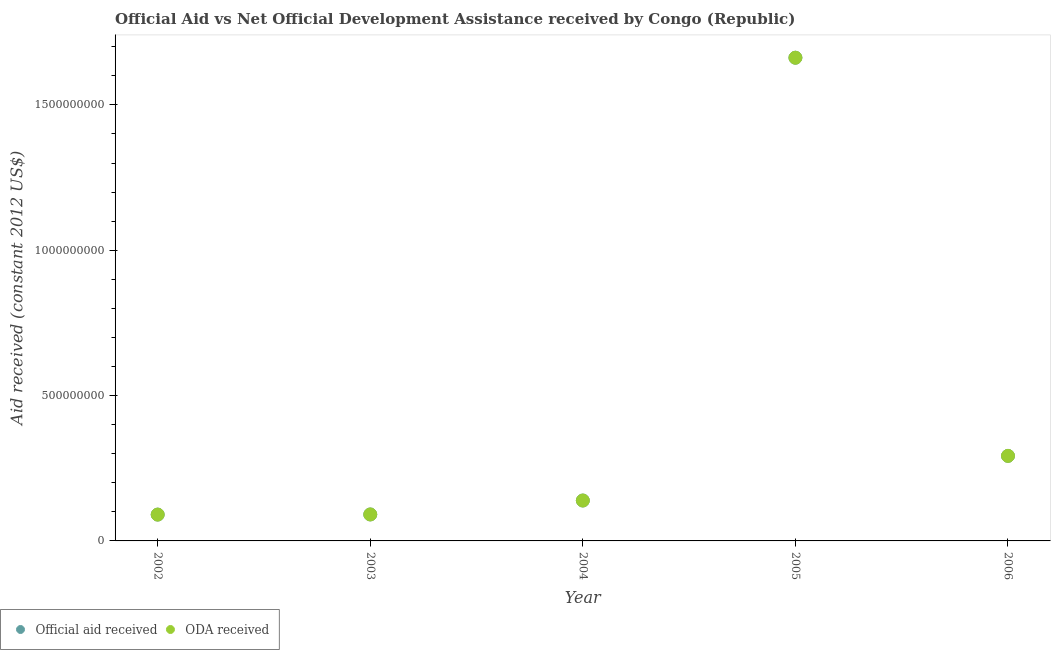How many different coloured dotlines are there?
Offer a very short reply. 2. What is the oda received in 2002?
Your answer should be compact. 9.06e+07. Across all years, what is the maximum official aid received?
Your response must be concise. 1.66e+09. Across all years, what is the minimum oda received?
Your answer should be compact. 9.06e+07. In which year was the oda received maximum?
Provide a short and direct response. 2005. In which year was the official aid received minimum?
Offer a terse response. 2002. What is the total official aid received in the graph?
Your response must be concise. 2.28e+09. What is the difference between the official aid received in 2005 and that in 2006?
Your answer should be compact. 1.37e+09. What is the difference between the official aid received in 2002 and the oda received in 2005?
Offer a very short reply. -1.57e+09. What is the average official aid received per year?
Provide a succinct answer. 4.55e+08. In the year 2005, what is the difference between the oda received and official aid received?
Your answer should be compact. 0. What is the ratio of the official aid received in 2004 to that in 2005?
Your response must be concise. 0.08. Is the difference between the official aid received in 2002 and 2006 greater than the difference between the oda received in 2002 and 2006?
Provide a short and direct response. No. What is the difference between the highest and the second highest oda received?
Offer a terse response. 1.37e+09. What is the difference between the highest and the lowest official aid received?
Keep it short and to the point. 1.57e+09. Is the sum of the official aid received in 2003 and 2004 greater than the maximum oda received across all years?
Ensure brevity in your answer.  No. Is the oda received strictly greater than the official aid received over the years?
Your answer should be very brief. No. Is the oda received strictly less than the official aid received over the years?
Your answer should be very brief. No. What is the difference between two consecutive major ticks on the Y-axis?
Offer a very short reply. 5.00e+08. How are the legend labels stacked?
Provide a succinct answer. Horizontal. What is the title of the graph?
Offer a terse response. Official Aid vs Net Official Development Assistance received by Congo (Republic) . What is the label or title of the X-axis?
Offer a terse response. Year. What is the label or title of the Y-axis?
Your answer should be compact. Aid received (constant 2012 US$). What is the Aid received (constant 2012 US$) in Official aid received in 2002?
Give a very brief answer. 9.06e+07. What is the Aid received (constant 2012 US$) in ODA received in 2002?
Ensure brevity in your answer.  9.06e+07. What is the Aid received (constant 2012 US$) of Official aid received in 2003?
Provide a short and direct response. 9.11e+07. What is the Aid received (constant 2012 US$) in ODA received in 2003?
Offer a terse response. 9.11e+07. What is the Aid received (constant 2012 US$) of Official aid received in 2004?
Give a very brief answer. 1.39e+08. What is the Aid received (constant 2012 US$) of ODA received in 2004?
Offer a very short reply. 1.39e+08. What is the Aid received (constant 2012 US$) of Official aid received in 2005?
Provide a succinct answer. 1.66e+09. What is the Aid received (constant 2012 US$) in ODA received in 2005?
Your answer should be very brief. 1.66e+09. What is the Aid received (constant 2012 US$) of Official aid received in 2006?
Provide a succinct answer. 2.93e+08. What is the Aid received (constant 2012 US$) in ODA received in 2006?
Make the answer very short. 2.93e+08. Across all years, what is the maximum Aid received (constant 2012 US$) of Official aid received?
Provide a short and direct response. 1.66e+09. Across all years, what is the maximum Aid received (constant 2012 US$) in ODA received?
Ensure brevity in your answer.  1.66e+09. Across all years, what is the minimum Aid received (constant 2012 US$) of Official aid received?
Make the answer very short. 9.06e+07. Across all years, what is the minimum Aid received (constant 2012 US$) of ODA received?
Provide a short and direct response. 9.06e+07. What is the total Aid received (constant 2012 US$) in Official aid received in the graph?
Offer a terse response. 2.28e+09. What is the total Aid received (constant 2012 US$) of ODA received in the graph?
Offer a very short reply. 2.28e+09. What is the difference between the Aid received (constant 2012 US$) in Official aid received in 2002 and that in 2003?
Your response must be concise. -5.00e+05. What is the difference between the Aid received (constant 2012 US$) in ODA received in 2002 and that in 2003?
Your answer should be very brief. -5.00e+05. What is the difference between the Aid received (constant 2012 US$) in Official aid received in 2002 and that in 2004?
Keep it short and to the point. -4.84e+07. What is the difference between the Aid received (constant 2012 US$) of ODA received in 2002 and that in 2004?
Provide a succinct answer. -4.84e+07. What is the difference between the Aid received (constant 2012 US$) of Official aid received in 2002 and that in 2005?
Give a very brief answer. -1.57e+09. What is the difference between the Aid received (constant 2012 US$) of ODA received in 2002 and that in 2005?
Keep it short and to the point. -1.57e+09. What is the difference between the Aid received (constant 2012 US$) in Official aid received in 2002 and that in 2006?
Provide a succinct answer. -2.02e+08. What is the difference between the Aid received (constant 2012 US$) in ODA received in 2002 and that in 2006?
Give a very brief answer. -2.02e+08. What is the difference between the Aid received (constant 2012 US$) of Official aid received in 2003 and that in 2004?
Give a very brief answer. -4.79e+07. What is the difference between the Aid received (constant 2012 US$) of ODA received in 2003 and that in 2004?
Offer a terse response. -4.79e+07. What is the difference between the Aid received (constant 2012 US$) in Official aid received in 2003 and that in 2005?
Your answer should be very brief. -1.57e+09. What is the difference between the Aid received (constant 2012 US$) of ODA received in 2003 and that in 2005?
Provide a short and direct response. -1.57e+09. What is the difference between the Aid received (constant 2012 US$) of Official aid received in 2003 and that in 2006?
Keep it short and to the point. -2.02e+08. What is the difference between the Aid received (constant 2012 US$) in ODA received in 2003 and that in 2006?
Offer a terse response. -2.02e+08. What is the difference between the Aid received (constant 2012 US$) of Official aid received in 2004 and that in 2005?
Ensure brevity in your answer.  -1.52e+09. What is the difference between the Aid received (constant 2012 US$) in ODA received in 2004 and that in 2005?
Ensure brevity in your answer.  -1.52e+09. What is the difference between the Aid received (constant 2012 US$) in Official aid received in 2004 and that in 2006?
Your answer should be compact. -1.54e+08. What is the difference between the Aid received (constant 2012 US$) of ODA received in 2004 and that in 2006?
Make the answer very short. -1.54e+08. What is the difference between the Aid received (constant 2012 US$) in Official aid received in 2005 and that in 2006?
Your response must be concise. 1.37e+09. What is the difference between the Aid received (constant 2012 US$) of ODA received in 2005 and that in 2006?
Keep it short and to the point. 1.37e+09. What is the difference between the Aid received (constant 2012 US$) in Official aid received in 2002 and the Aid received (constant 2012 US$) in ODA received in 2003?
Offer a very short reply. -5.00e+05. What is the difference between the Aid received (constant 2012 US$) of Official aid received in 2002 and the Aid received (constant 2012 US$) of ODA received in 2004?
Provide a succinct answer. -4.84e+07. What is the difference between the Aid received (constant 2012 US$) in Official aid received in 2002 and the Aid received (constant 2012 US$) in ODA received in 2005?
Keep it short and to the point. -1.57e+09. What is the difference between the Aid received (constant 2012 US$) in Official aid received in 2002 and the Aid received (constant 2012 US$) in ODA received in 2006?
Your answer should be compact. -2.02e+08. What is the difference between the Aid received (constant 2012 US$) in Official aid received in 2003 and the Aid received (constant 2012 US$) in ODA received in 2004?
Provide a succinct answer. -4.79e+07. What is the difference between the Aid received (constant 2012 US$) of Official aid received in 2003 and the Aid received (constant 2012 US$) of ODA received in 2005?
Your response must be concise. -1.57e+09. What is the difference between the Aid received (constant 2012 US$) of Official aid received in 2003 and the Aid received (constant 2012 US$) of ODA received in 2006?
Your answer should be very brief. -2.02e+08. What is the difference between the Aid received (constant 2012 US$) in Official aid received in 2004 and the Aid received (constant 2012 US$) in ODA received in 2005?
Offer a very short reply. -1.52e+09. What is the difference between the Aid received (constant 2012 US$) in Official aid received in 2004 and the Aid received (constant 2012 US$) in ODA received in 2006?
Your answer should be very brief. -1.54e+08. What is the difference between the Aid received (constant 2012 US$) of Official aid received in 2005 and the Aid received (constant 2012 US$) of ODA received in 2006?
Provide a succinct answer. 1.37e+09. What is the average Aid received (constant 2012 US$) in Official aid received per year?
Your answer should be compact. 4.55e+08. What is the average Aid received (constant 2012 US$) in ODA received per year?
Ensure brevity in your answer.  4.55e+08. In the year 2003, what is the difference between the Aid received (constant 2012 US$) in Official aid received and Aid received (constant 2012 US$) in ODA received?
Your answer should be compact. 0. In the year 2004, what is the difference between the Aid received (constant 2012 US$) in Official aid received and Aid received (constant 2012 US$) in ODA received?
Keep it short and to the point. 0. In the year 2006, what is the difference between the Aid received (constant 2012 US$) in Official aid received and Aid received (constant 2012 US$) in ODA received?
Your answer should be compact. 0. What is the ratio of the Aid received (constant 2012 US$) of Official aid received in 2002 to that in 2004?
Offer a terse response. 0.65. What is the ratio of the Aid received (constant 2012 US$) of ODA received in 2002 to that in 2004?
Give a very brief answer. 0.65. What is the ratio of the Aid received (constant 2012 US$) of Official aid received in 2002 to that in 2005?
Your answer should be compact. 0.05. What is the ratio of the Aid received (constant 2012 US$) in ODA received in 2002 to that in 2005?
Ensure brevity in your answer.  0.05. What is the ratio of the Aid received (constant 2012 US$) of Official aid received in 2002 to that in 2006?
Your response must be concise. 0.31. What is the ratio of the Aid received (constant 2012 US$) in ODA received in 2002 to that in 2006?
Keep it short and to the point. 0.31. What is the ratio of the Aid received (constant 2012 US$) of Official aid received in 2003 to that in 2004?
Provide a short and direct response. 0.66. What is the ratio of the Aid received (constant 2012 US$) in ODA received in 2003 to that in 2004?
Provide a succinct answer. 0.66. What is the ratio of the Aid received (constant 2012 US$) of Official aid received in 2003 to that in 2005?
Provide a short and direct response. 0.05. What is the ratio of the Aid received (constant 2012 US$) in ODA received in 2003 to that in 2005?
Give a very brief answer. 0.05. What is the ratio of the Aid received (constant 2012 US$) of Official aid received in 2003 to that in 2006?
Your answer should be compact. 0.31. What is the ratio of the Aid received (constant 2012 US$) in ODA received in 2003 to that in 2006?
Your response must be concise. 0.31. What is the ratio of the Aid received (constant 2012 US$) of Official aid received in 2004 to that in 2005?
Ensure brevity in your answer.  0.08. What is the ratio of the Aid received (constant 2012 US$) of ODA received in 2004 to that in 2005?
Offer a very short reply. 0.08. What is the ratio of the Aid received (constant 2012 US$) in Official aid received in 2004 to that in 2006?
Your response must be concise. 0.48. What is the ratio of the Aid received (constant 2012 US$) in ODA received in 2004 to that in 2006?
Keep it short and to the point. 0.48. What is the ratio of the Aid received (constant 2012 US$) in Official aid received in 2005 to that in 2006?
Your response must be concise. 5.68. What is the ratio of the Aid received (constant 2012 US$) in ODA received in 2005 to that in 2006?
Your answer should be very brief. 5.68. What is the difference between the highest and the second highest Aid received (constant 2012 US$) in Official aid received?
Your response must be concise. 1.37e+09. What is the difference between the highest and the second highest Aid received (constant 2012 US$) in ODA received?
Your response must be concise. 1.37e+09. What is the difference between the highest and the lowest Aid received (constant 2012 US$) of Official aid received?
Keep it short and to the point. 1.57e+09. What is the difference between the highest and the lowest Aid received (constant 2012 US$) in ODA received?
Make the answer very short. 1.57e+09. 